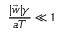Convert formula to latex. <formula><loc_0><loc_0><loc_500><loc_500>\frac { | \vec { w } | \gamma } { a T } \ll 1</formula> 